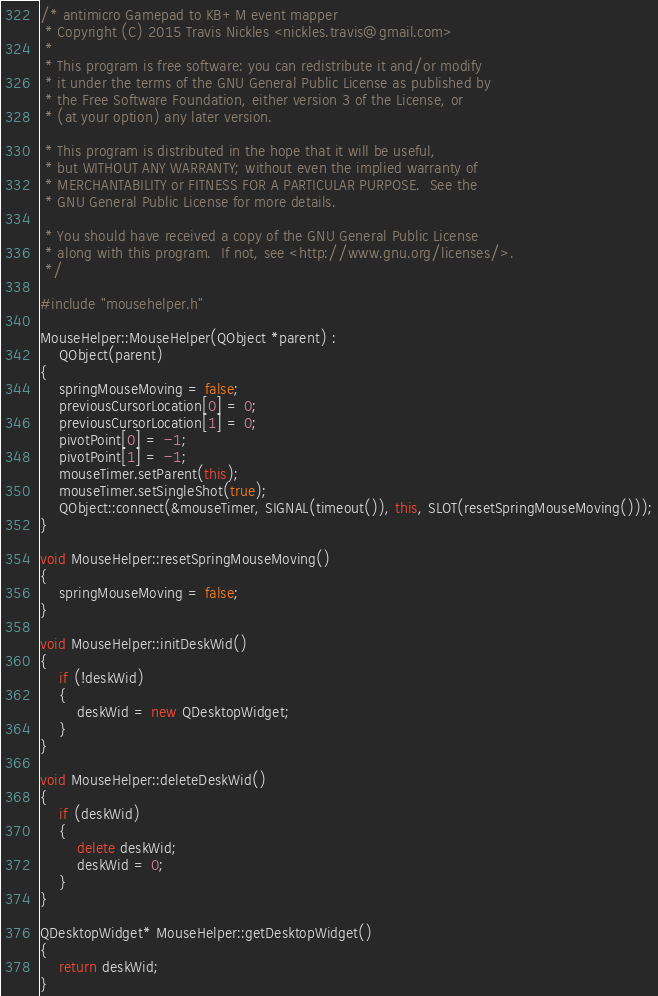Convert code to text. <code><loc_0><loc_0><loc_500><loc_500><_C++_>/* antimicro Gamepad to KB+M event mapper
 * Copyright (C) 2015 Travis Nickles <nickles.travis@gmail.com>
 *
 * This program is free software: you can redistribute it and/or modify
 * it under the terms of the GNU General Public License as published by
 * the Free Software Foundation, either version 3 of the License, or
 * (at your option) any later version.

 * This program is distributed in the hope that it will be useful,
 * but WITHOUT ANY WARRANTY; without even the implied warranty of
 * MERCHANTABILITY or FITNESS FOR A PARTICULAR PURPOSE.  See the
 * GNU General Public License for more details.

 * You should have received a copy of the GNU General Public License
 * along with this program.  If not, see <http://www.gnu.org/licenses/>.
 */

#include "mousehelper.h"

MouseHelper::MouseHelper(QObject *parent) :
    QObject(parent)
{
    springMouseMoving = false;
    previousCursorLocation[0] = 0;
    previousCursorLocation[1] = 0;
    pivotPoint[0] = -1;
    pivotPoint[1] = -1;
    mouseTimer.setParent(this);
    mouseTimer.setSingleShot(true);
    QObject::connect(&mouseTimer, SIGNAL(timeout()), this, SLOT(resetSpringMouseMoving()));
}

void MouseHelper::resetSpringMouseMoving()
{
    springMouseMoving = false;
}

void MouseHelper::initDeskWid()
{
    if (!deskWid)
    {
        deskWid = new QDesktopWidget;
    }
}

void MouseHelper::deleteDeskWid()
{
    if (deskWid)
    {
        delete deskWid;
        deskWid = 0;
    }
}

QDesktopWidget* MouseHelper::getDesktopWidget()
{
    return deskWid;
}
</code> 